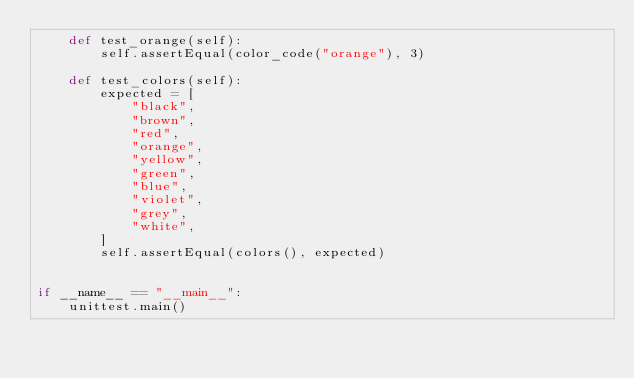Convert code to text. <code><loc_0><loc_0><loc_500><loc_500><_Python_>    def test_orange(self):
        self.assertEqual(color_code("orange"), 3)

    def test_colors(self):
        expected = [
            "black",
            "brown",
            "red",
            "orange",
            "yellow",
            "green",
            "blue",
            "violet",
            "grey",
            "white",
        ]
        self.assertEqual(colors(), expected)


if __name__ == "__main__":
    unittest.main()
</code> 